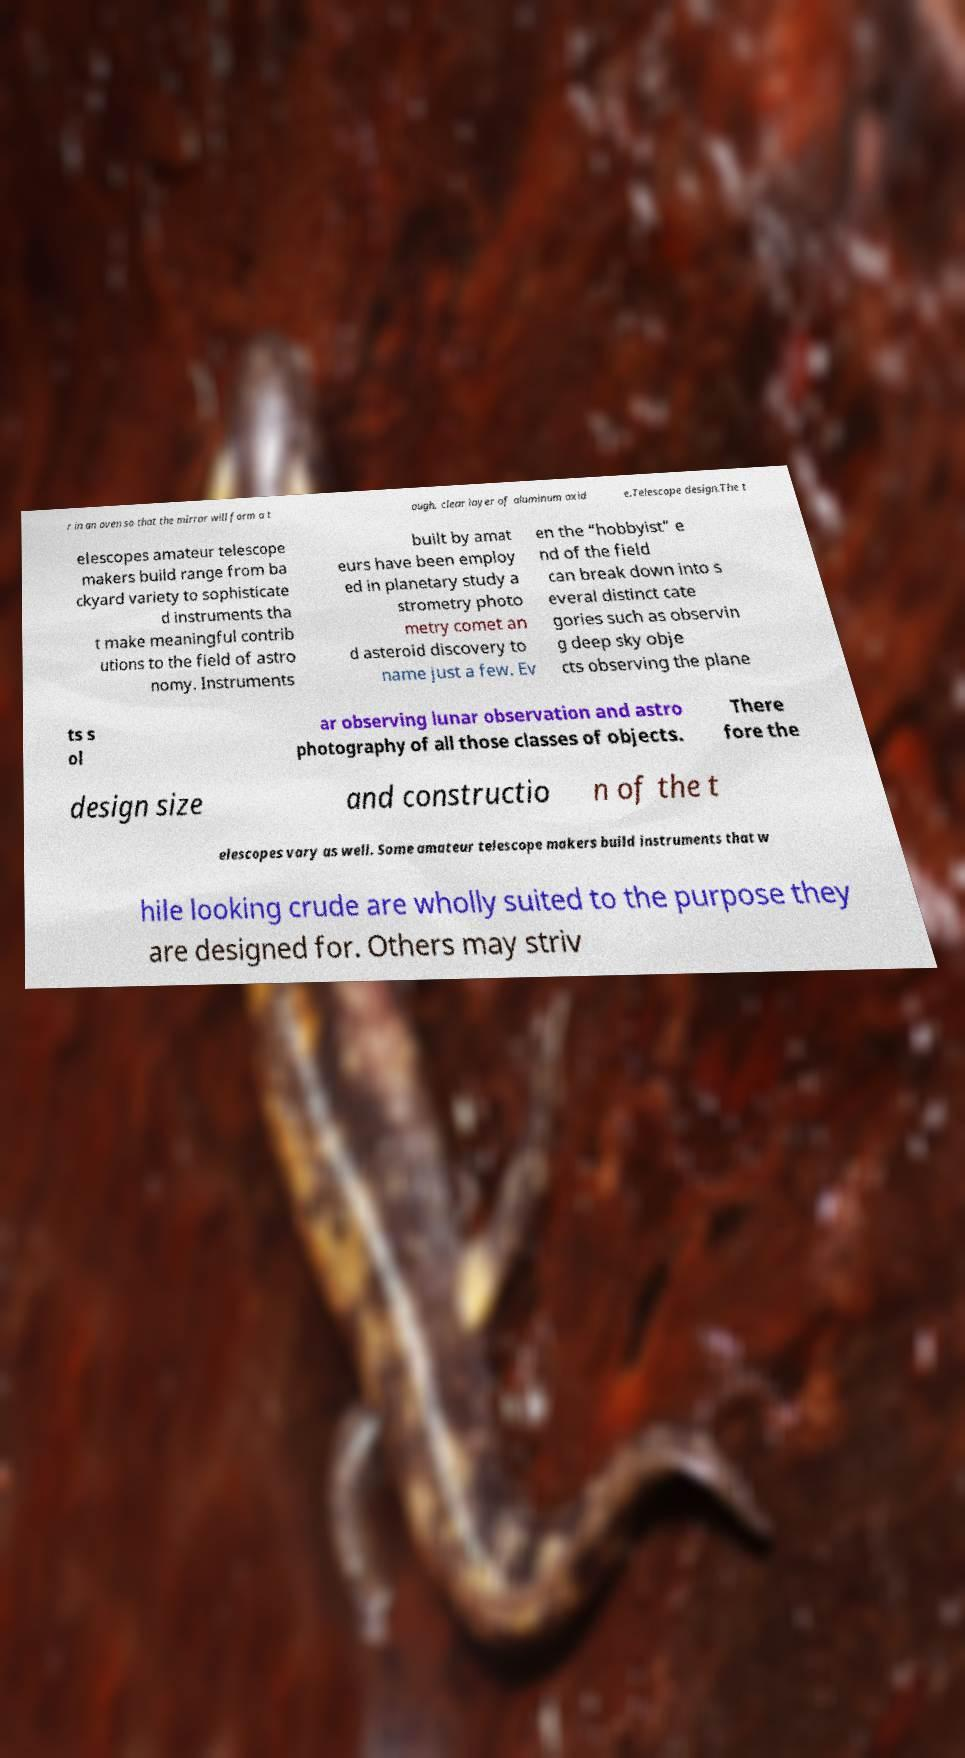Please read and relay the text visible in this image. What does it say? r in an oven so that the mirror will form a t ough, clear layer of aluminum oxid e.Telescope design.The t elescopes amateur telescope makers build range from ba ckyard variety to sophisticate d instruments tha t make meaningful contrib utions to the field of astro nomy. Instruments built by amat eurs have been employ ed in planetary study a strometry photo metry comet an d asteroid discovery to name just a few. Ev en the “hobbyist” e nd of the field can break down into s everal distinct cate gories such as observin g deep sky obje cts observing the plane ts s ol ar observing lunar observation and astro photography of all those classes of objects. There fore the design size and constructio n of the t elescopes vary as well. Some amateur telescope makers build instruments that w hile looking crude are wholly suited to the purpose they are designed for. Others may striv 